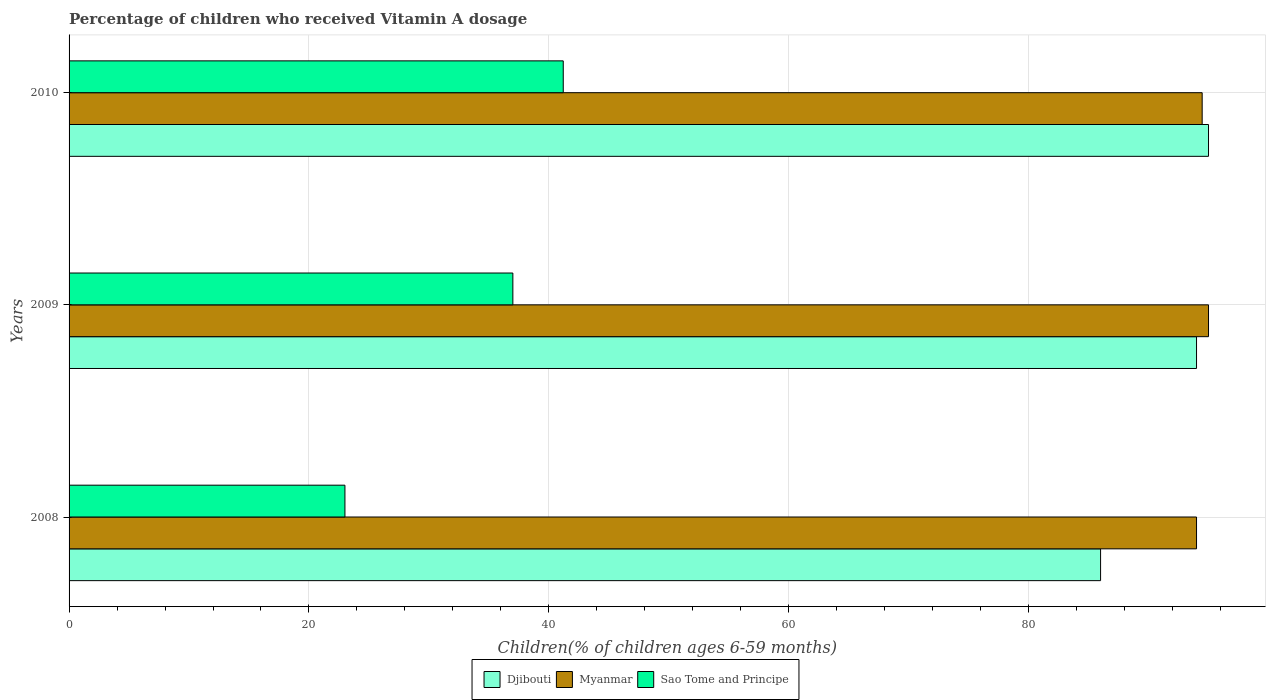How many groups of bars are there?
Your response must be concise. 3. How many bars are there on the 3rd tick from the bottom?
Offer a very short reply. 3. What is the label of the 2nd group of bars from the top?
Ensure brevity in your answer.  2009. In how many cases, is the number of bars for a given year not equal to the number of legend labels?
Provide a short and direct response. 0. What is the percentage of children who received Vitamin A dosage in Djibouti in 2009?
Offer a terse response. 94. Across all years, what is the maximum percentage of children who received Vitamin A dosage in Sao Tome and Principe?
Provide a succinct answer. 41.2. In which year was the percentage of children who received Vitamin A dosage in Sao Tome and Principe minimum?
Give a very brief answer. 2008. What is the total percentage of children who received Vitamin A dosage in Djibouti in the graph?
Provide a short and direct response. 275. What is the difference between the percentage of children who received Vitamin A dosage in Djibouti in 2008 and that in 2009?
Ensure brevity in your answer.  -8. What is the difference between the percentage of children who received Vitamin A dosage in Sao Tome and Principe in 2009 and the percentage of children who received Vitamin A dosage in Djibouti in 2008?
Your answer should be compact. -49. What is the average percentage of children who received Vitamin A dosage in Sao Tome and Principe per year?
Provide a short and direct response. 33.73. In the year 2008, what is the difference between the percentage of children who received Vitamin A dosage in Sao Tome and Principe and percentage of children who received Vitamin A dosage in Myanmar?
Give a very brief answer. -71. In how many years, is the percentage of children who received Vitamin A dosage in Sao Tome and Principe greater than 4 %?
Your response must be concise. 3. What is the ratio of the percentage of children who received Vitamin A dosage in Myanmar in 2008 to that in 2009?
Keep it short and to the point. 0.99. Is the percentage of children who received Vitamin A dosage in Djibouti in 2008 less than that in 2009?
Your response must be concise. Yes. Is the difference between the percentage of children who received Vitamin A dosage in Sao Tome and Principe in 2009 and 2010 greater than the difference between the percentage of children who received Vitamin A dosage in Myanmar in 2009 and 2010?
Keep it short and to the point. No. What is the difference between the highest and the second highest percentage of children who received Vitamin A dosage in Djibouti?
Provide a succinct answer. 1. What is the difference between the highest and the lowest percentage of children who received Vitamin A dosage in Sao Tome and Principe?
Your answer should be compact. 18.2. In how many years, is the percentage of children who received Vitamin A dosage in Sao Tome and Principe greater than the average percentage of children who received Vitamin A dosage in Sao Tome and Principe taken over all years?
Your answer should be compact. 2. What does the 1st bar from the top in 2009 represents?
Keep it short and to the point. Sao Tome and Principe. What does the 3rd bar from the bottom in 2010 represents?
Your answer should be compact. Sao Tome and Principe. How many years are there in the graph?
Provide a short and direct response. 3. What is the difference between two consecutive major ticks on the X-axis?
Give a very brief answer. 20. Does the graph contain grids?
Provide a short and direct response. Yes. How many legend labels are there?
Provide a succinct answer. 3. How are the legend labels stacked?
Your response must be concise. Horizontal. What is the title of the graph?
Your answer should be very brief. Percentage of children who received Vitamin A dosage. Does "Syrian Arab Republic" appear as one of the legend labels in the graph?
Your response must be concise. No. What is the label or title of the X-axis?
Ensure brevity in your answer.  Children(% of children ages 6-59 months). What is the label or title of the Y-axis?
Keep it short and to the point. Years. What is the Children(% of children ages 6-59 months) in Myanmar in 2008?
Provide a short and direct response. 94. What is the Children(% of children ages 6-59 months) of Sao Tome and Principe in 2008?
Make the answer very short. 23. What is the Children(% of children ages 6-59 months) of Djibouti in 2009?
Your response must be concise. 94. What is the Children(% of children ages 6-59 months) of Djibouti in 2010?
Your answer should be very brief. 95. What is the Children(% of children ages 6-59 months) in Myanmar in 2010?
Keep it short and to the point. 94.47. What is the Children(% of children ages 6-59 months) of Sao Tome and Principe in 2010?
Offer a terse response. 41.2. Across all years, what is the maximum Children(% of children ages 6-59 months) in Sao Tome and Principe?
Make the answer very short. 41.2. Across all years, what is the minimum Children(% of children ages 6-59 months) in Myanmar?
Offer a terse response. 94. Across all years, what is the minimum Children(% of children ages 6-59 months) in Sao Tome and Principe?
Keep it short and to the point. 23. What is the total Children(% of children ages 6-59 months) in Djibouti in the graph?
Offer a very short reply. 275. What is the total Children(% of children ages 6-59 months) of Myanmar in the graph?
Your response must be concise. 283.47. What is the total Children(% of children ages 6-59 months) in Sao Tome and Principe in the graph?
Provide a short and direct response. 101.2. What is the difference between the Children(% of children ages 6-59 months) of Myanmar in 2008 and that in 2010?
Offer a terse response. -0.47. What is the difference between the Children(% of children ages 6-59 months) of Sao Tome and Principe in 2008 and that in 2010?
Your response must be concise. -18.2. What is the difference between the Children(% of children ages 6-59 months) of Djibouti in 2009 and that in 2010?
Your answer should be very brief. -1. What is the difference between the Children(% of children ages 6-59 months) in Myanmar in 2009 and that in 2010?
Offer a terse response. 0.53. What is the difference between the Children(% of children ages 6-59 months) of Sao Tome and Principe in 2009 and that in 2010?
Provide a short and direct response. -4.2. What is the difference between the Children(% of children ages 6-59 months) in Djibouti in 2008 and the Children(% of children ages 6-59 months) in Myanmar in 2010?
Give a very brief answer. -8.47. What is the difference between the Children(% of children ages 6-59 months) of Djibouti in 2008 and the Children(% of children ages 6-59 months) of Sao Tome and Principe in 2010?
Your answer should be compact. 44.8. What is the difference between the Children(% of children ages 6-59 months) of Myanmar in 2008 and the Children(% of children ages 6-59 months) of Sao Tome and Principe in 2010?
Provide a succinct answer. 52.8. What is the difference between the Children(% of children ages 6-59 months) of Djibouti in 2009 and the Children(% of children ages 6-59 months) of Myanmar in 2010?
Your answer should be very brief. -0.47. What is the difference between the Children(% of children ages 6-59 months) of Djibouti in 2009 and the Children(% of children ages 6-59 months) of Sao Tome and Principe in 2010?
Give a very brief answer. 52.8. What is the difference between the Children(% of children ages 6-59 months) in Myanmar in 2009 and the Children(% of children ages 6-59 months) in Sao Tome and Principe in 2010?
Your response must be concise. 53.8. What is the average Children(% of children ages 6-59 months) of Djibouti per year?
Your answer should be compact. 91.67. What is the average Children(% of children ages 6-59 months) of Myanmar per year?
Provide a short and direct response. 94.49. What is the average Children(% of children ages 6-59 months) of Sao Tome and Principe per year?
Give a very brief answer. 33.73. In the year 2008, what is the difference between the Children(% of children ages 6-59 months) in Djibouti and Children(% of children ages 6-59 months) in Myanmar?
Provide a succinct answer. -8. In the year 2008, what is the difference between the Children(% of children ages 6-59 months) in Djibouti and Children(% of children ages 6-59 months) in Sao Tome and Principe?
Provide a succinct answer. 63. In the year 2009, what is the difference between the Children(% of children ages 6-59 months) in Djibouti and Children(% of children ages 6-59 months) in Myanmar?
Your response must be concise. -1. In the year 2009, what is the difference between the Children(% of children ages 6-59 months) of Djibouti and Children(% of children ages 6-59 months) of Sao Tome and Principe?
Provide a succinct answer. 57. In the year 2010, what is the difference between the Children(% of children ages 6-59 months) in Djibouti and Children(% of children ages 6-59 months) in Myanmar?
Your answer should be compact. 0.53. In the year 2010, what is the difference between the Children(% of children ages 6-59 months) of Djibouti and Children(% of children ages 6-59 months) of Sao Tome and Principe?
Offer a terse response. 53.8. In the year 2010, what is the difference between the Children(% of children ages 6-59 months) of Myanmar and Children(% of children ages 6-59 months) of Sao Tome and Principe?
Make the answer very short. 53.27. What is the ratio of the Children(% of children ages 6-59 months) of Djibouti in 2008 to that in 2009?
Offer a terse response. 0.91. What is the ratio of the Children(% of children ages 6-59 months) in Myanmar in 2008 to that in 2009?
Make the answer very short. 0.99. What is the ratio of the Children(% of children ages 6-59 months) in Sao Tome and Principe in 2008 to that in 2009?
Your answer should be very brief. 0.62. What is the ratio of the Children(% of children ages 6-59 months) of Djibouti in 2008 to that in 2010?
Provide a short and direct response. 0.91. What is the ratio of the Children(% of children ages 6-59 months) of Sao Tome and Principe in 2008 to that in 2010?
Provide a short and direct response. 0.56. What is the ratio of the Children(% of children ages 6-59 months) in Myanmar in 2009 to that in 2010?
Your answer should be compact. 1.01. What is the ratio of the Children(% of children ages 6-59 months) of Sao Tome and Principe in 2009 to that in 2010?
Offer a very short reply. 0.9. What is the difference between the highest and the second highest Children(% of children ages 6-59 months) in Djibouti?
Give a very brief answer. 1. What is the difference between the highest and the second highest Children(% of children ages 6-59 months) in Myanmar?
Provide a short and direct response. 0.53. What is the difference between the highest and the second highest Children(% of children ages 6-59 months) in Sao Tome and Principe?
Give a very brief answer. 4.2. What is the difference between the highest and the lowest Children(% of children ages 6-59 months) of Myanmar?
Ensure brevity in your answer.  1. What is the difference between the highest and the lowest Children(% of children ages 6-59 months) in Sao Tome and Principe?
Provide a short and direct response. 18.2. 